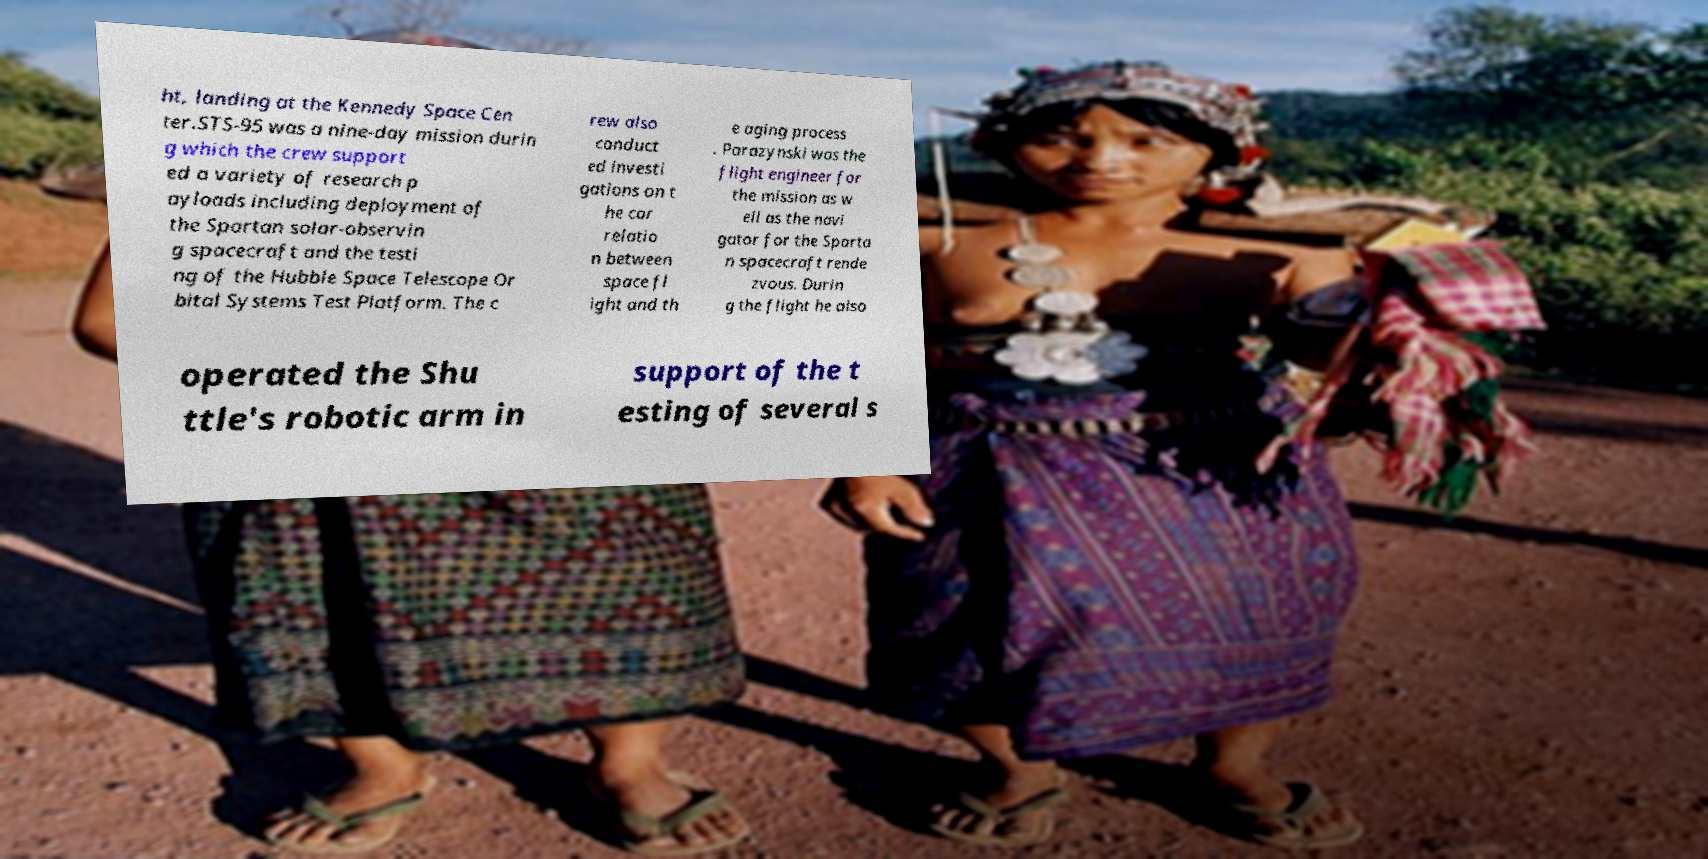What messages or text are displayed in this image? I need them in a readable, typed format. ht, landing at the Kennedy Space Cen ter.STS-95 was a nine-day mission durin g which the crew support ed a variety of research p ayloads including deployment of the Spartan solar-observin g spacecraft and the testi ng of the Hubble Space Telescope Or bital Systems Test Platform. The c rew also conduct ed investi gations on t he cor relatio n between space fl ight and th e aging process . Parazynski was the flight engineer for the mission as w ell as the navi gator for the Sparta n spacecraft rende zvous. Durin g the flight he also operated the Shu ttle's robotic arm in support of the t esting of several s 